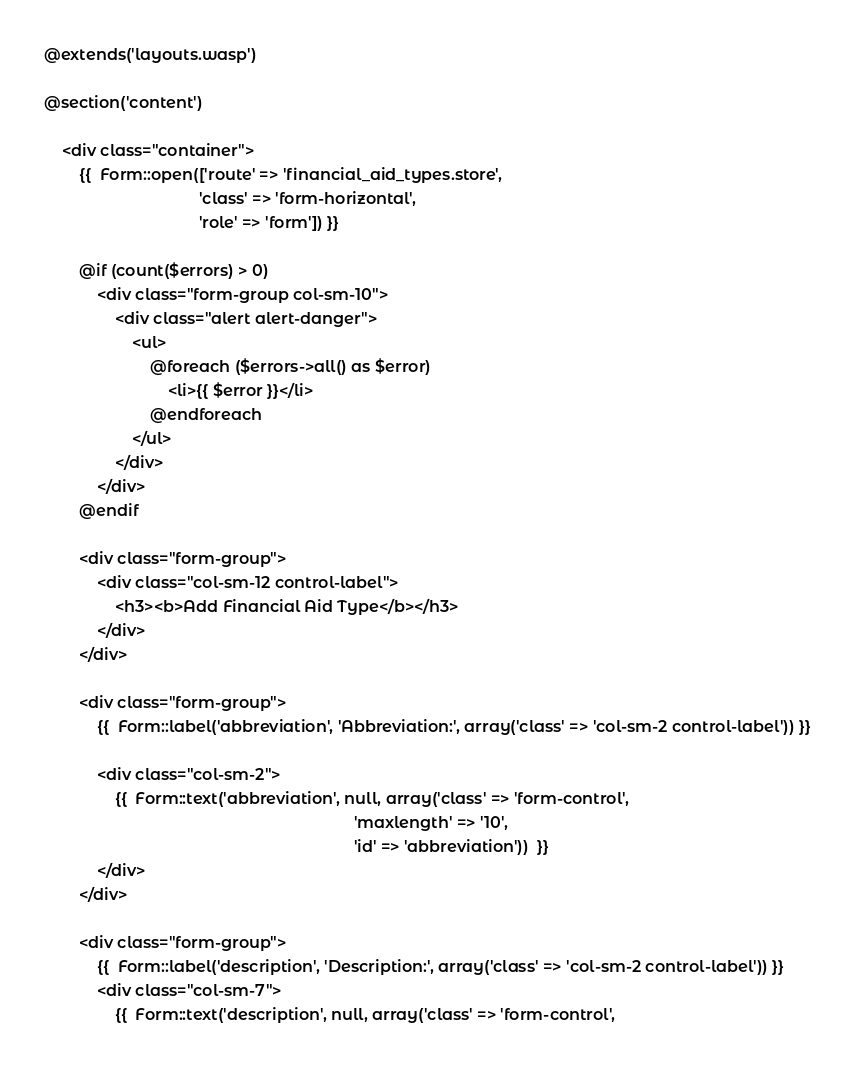Convert code to text. <code><loc_0><loc_0><loc_500><loc_500><_PHP_>@extends('layouts.wasp')

@section('content')

    <div class="container">
        {{  Form::open(['route' => 'financial_aid_types.store',
                                   'class' => 'form-horizontal',
                                   'role' => 'form']) }}

        @if (count($errors) > 0)
            <div class="form-group col-sm-10">
                <div class="alert alert-danger">
                    <ul>
                        @foreach ($errors->all() as $error)
                            <li>{{ $error }}</li>
                        @endforeach
                    </ul>
                </div>
            </div>
        @endif

        <div class="form-group">
            <div class="col-sm-12 control-label">
                <h3><b>Add Financial Aid Type</b></h3>
            </div>
        </div>

        <div class="form-group">
            {{  Form::label('abbreviation', 'Abbreviation:', array('class' => 'col-sm-2 control-label')) }}

            <div class="col-sm-2">
                {{  Form::text('abbreviation', null, array('class' => 'form-control',
                                                                      'maxlength' => '10',
                                                                      'id' => 'abbreviation'))  }}
            </div>
        </div>

        <div class="form-group">
            {{  Form::label('description', 'Description:', array('class' => 'col-sm-2 control-label')) }}
            <div class="col-sm-7">
                {{  Form::text('description', null, array('class' => 'form-control',</code> 